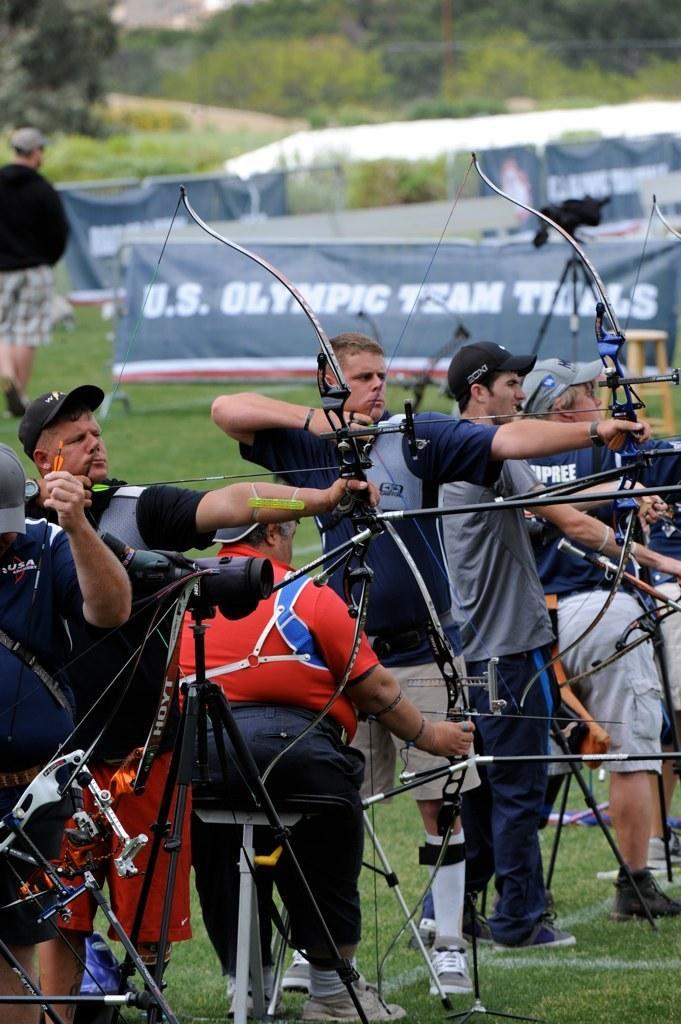Could you give a brief overview of what you see in this image? In this image in the middle, there is a man, he wears a t shirt, trouser, shoes, he is holding a bow and arrow, he is sitting, in front of him there is a man, he wears a t shirt, trouser, shoes, he is holding a bow and arrow. On the left there is a man, he wears a t shirt, trouser, cap, he is holding a bow and arrow. On the right there is a man, he wears a t shirt, trouser, shoes, he is holding a bow and arrow and there are some people. At the bottom there is a grass. In the background there are posters, cameraman, trees and plants. 